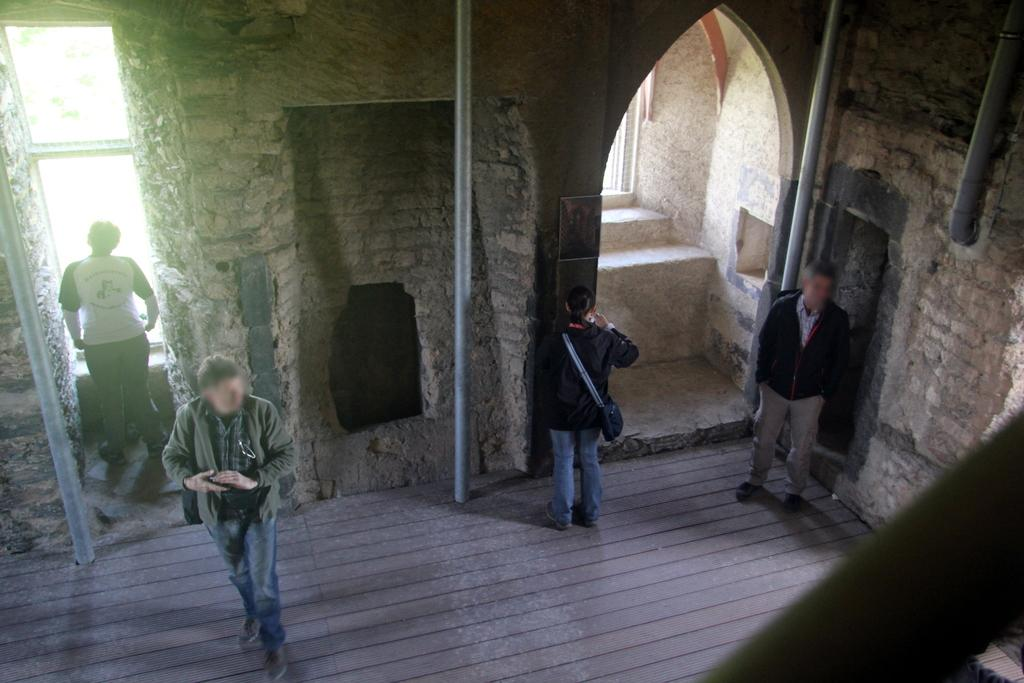Where was the image taken? The image was taken inside a fort. How many people can be seen in the image? There are many people standing in the image. What architectural features are visible in the background of the image? There are windows, doors, and pipes in the background of the image. What nation is responsible for the intricate detail on the pipes in the image? There is no information about the nation responsible for the pipes in the image, nor is there any detail mentioned on the pipes. 